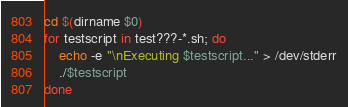<code> <loc_0><loc_0><loc_500><loc_500><_Bash_>
cd $(dirname $0)
for testscript in test???-*.sh; do
    echo -e "\nExecuting $testscript..." > /dev/stderr
    ./$testscript
done
</code> 